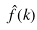<formula> <loc_0><loc_0><loc_500><loc_500>\hat { f } ( k )</formula> 